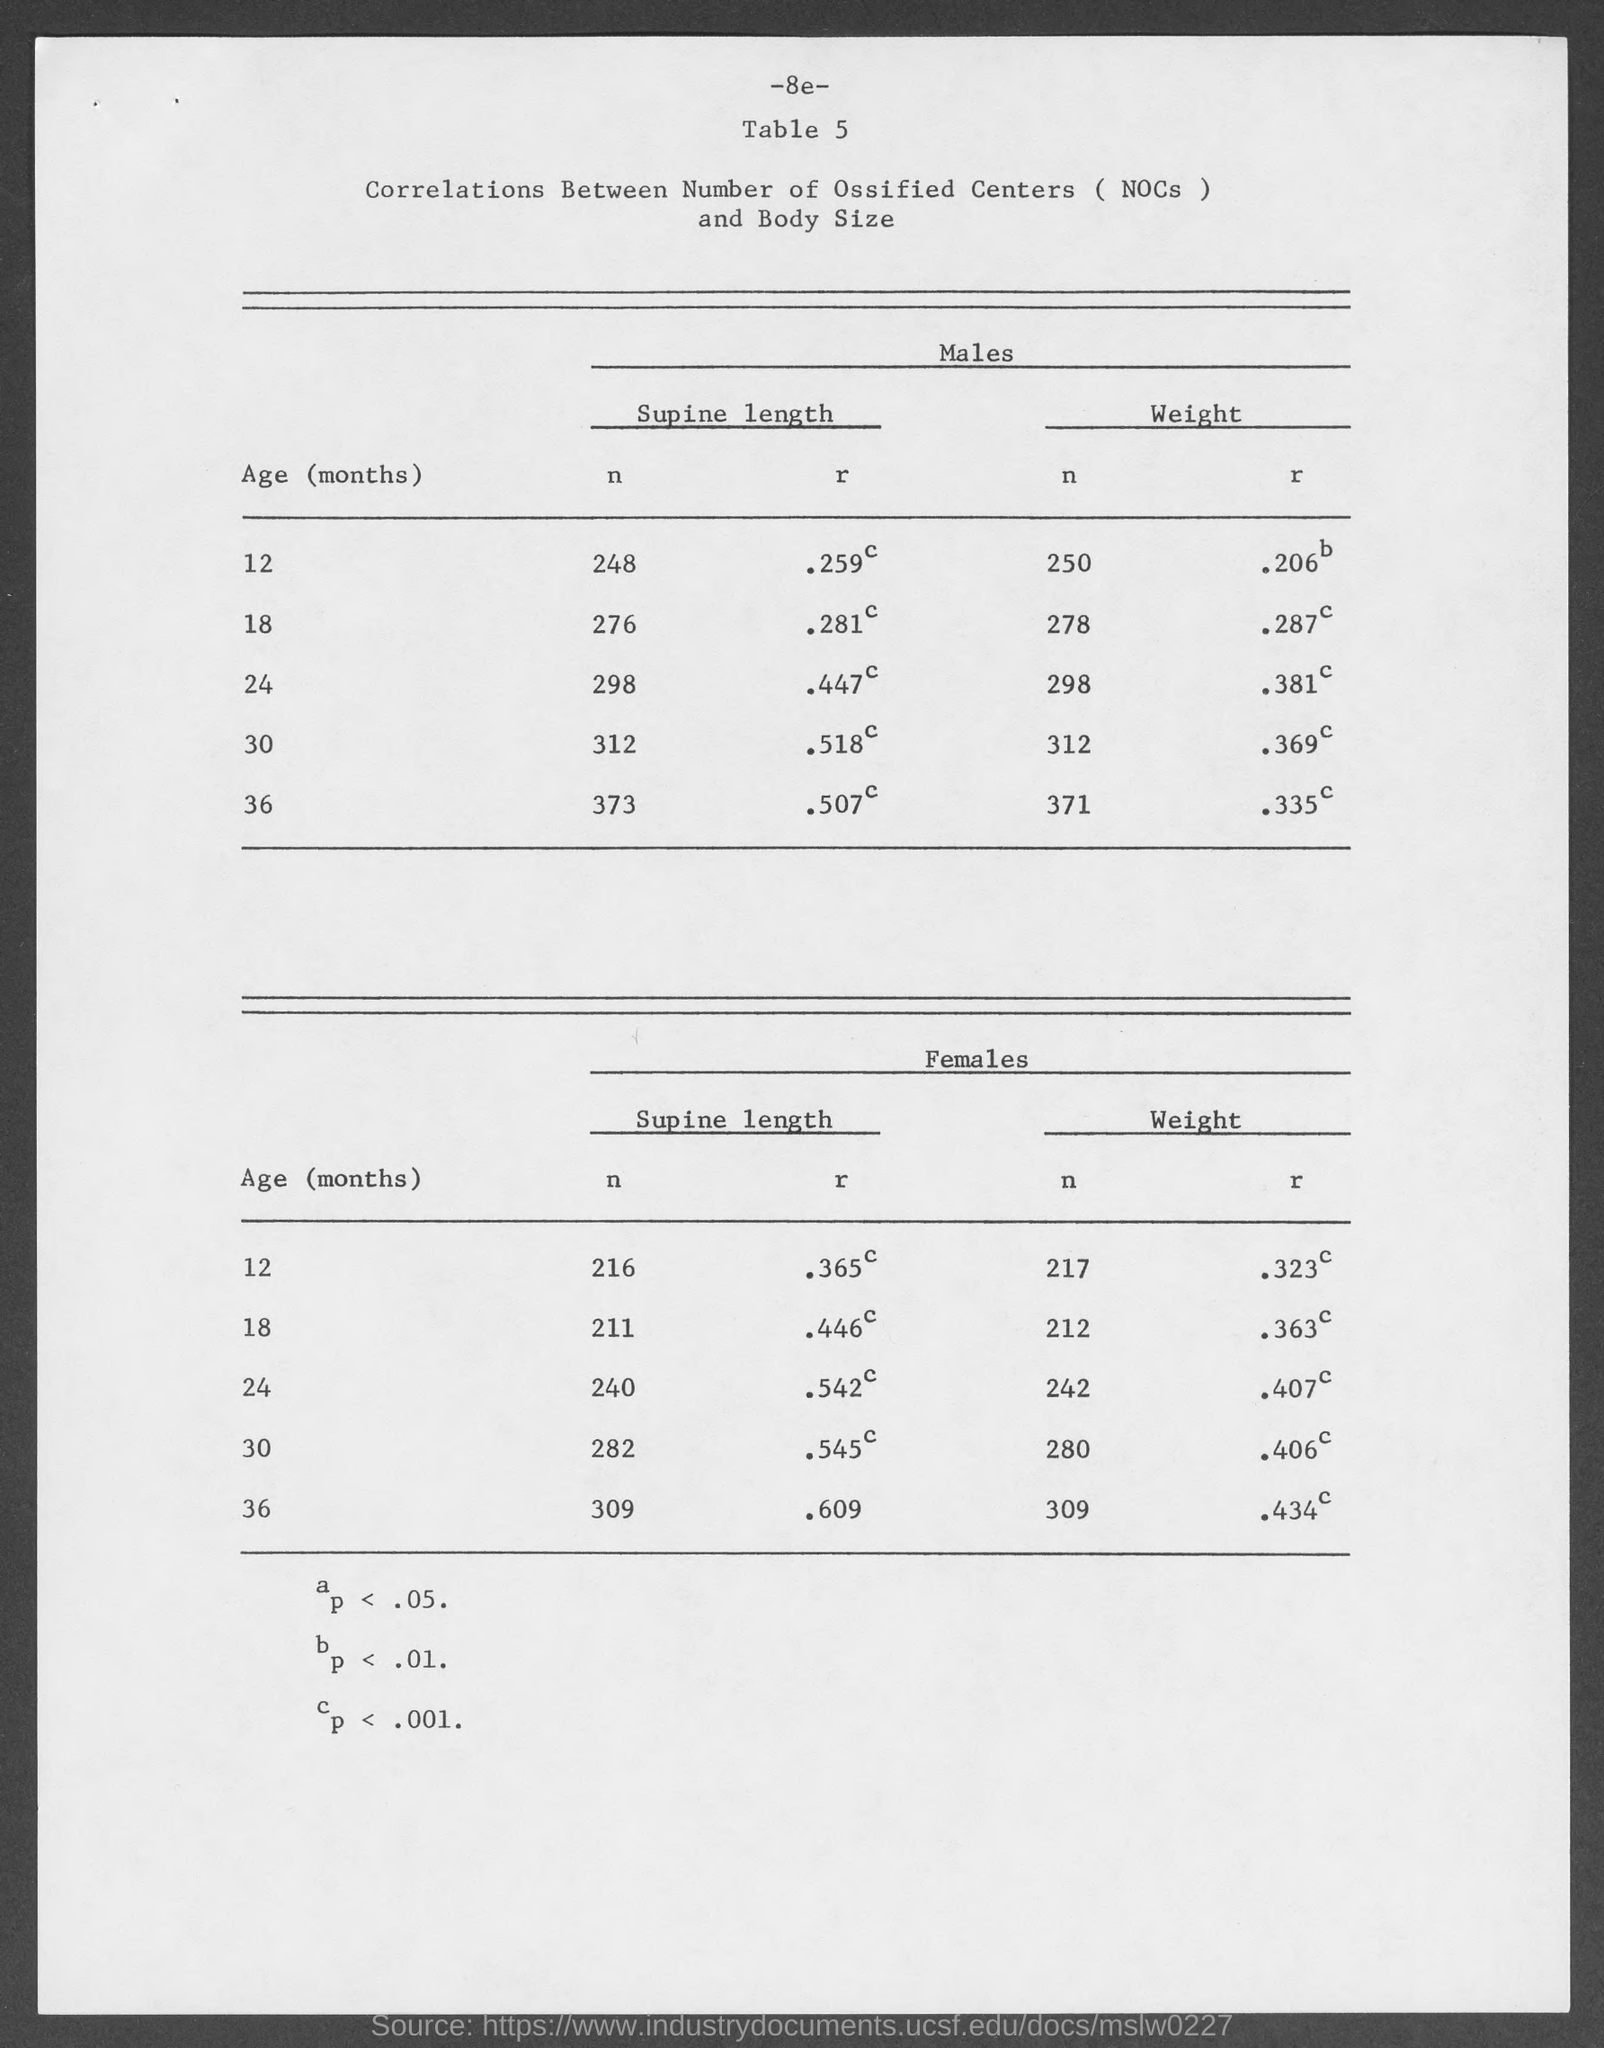Draw attention to some important aspects in this diagram. The supine length of n for males at the age of 18 months is 276 centimeters. The weight of males at the age of 18 months is 278. The weight of 12-month-old males is 250. The supine length of n for males at the age of 12 months is 248. The supine length of 30-month-old males is [insert measurement]. 